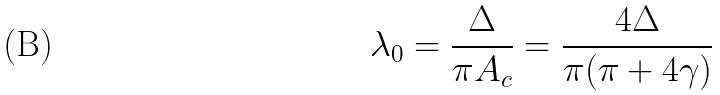<formula> <loc_0><loc_0><loc_500><loc_500>\lambda _ { 0 } = \frac { \Delta } { \pi A _ { c } } = \frac { 4 \Delta } { \pi ( \pi + 4 \gamma ) }</formula> 